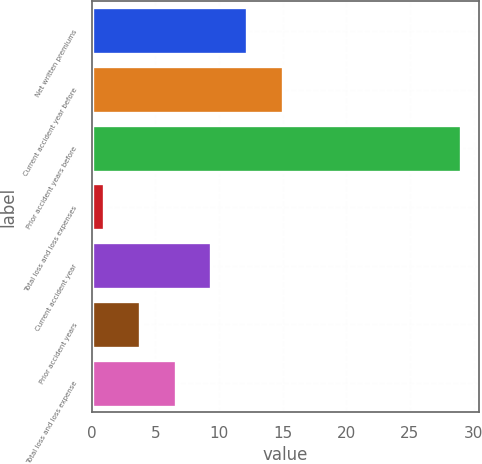<chart> <loc_0><loc_0><loc_500><loc_500><bar_chart><fcel>Net written premiums<fcel>Current accident year before<fcel>Prior accident years before<fcel>Total loss and loss expenses<fcel>Current accident year<fcel>Prior accident years<fcel>Total loss and loss expense<nl><fcel>12.2<fcel>15<fcel>29<fcel>1<fcel>9.4<fcel>3.8<fcel>6.6<nl></chart> 